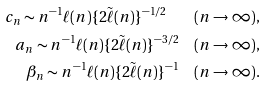<formula> <loc_0><loc_0><loc_500><loc_500>c _ { n } \sim n ^ { - 1 } \ell ( n ) \{ 2 \tilde { \ell } ( n ) \} ^ { - 1 / 2 } \quad ( n \to \infty ) , \\ a _ { n } \sim n ^ { - 1 } \ell ( n ) \{ 2 \tilde { \ell } ( n ) \} ^ { - 3 / 2 } \quad ( n \to \infty ) , \\ \beta _ { n } \sim n ^ { - 1 } \ell ( n ) \{ 2 \tilde { \ell } ( n ) \} ^ { - 1 } \quad ( n \to \infty ) .</formula> 